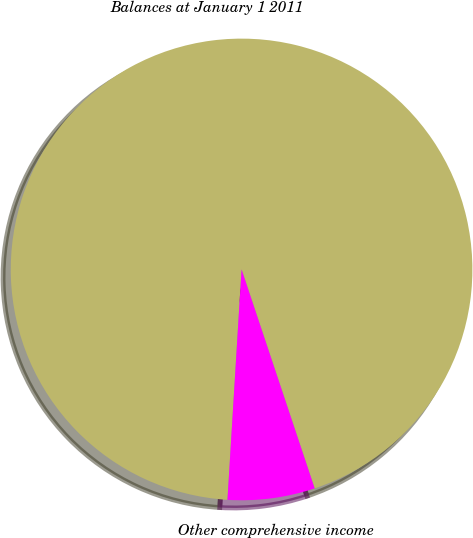Convert chart. <chart><loc_0><loc_0><loc_500><loc_500><pie_chart><fcel>Balances at January 1 2011<fcel>Other comprehensive income<nl><fcel>93.9%<fcel>6.1%<nl></chart> 